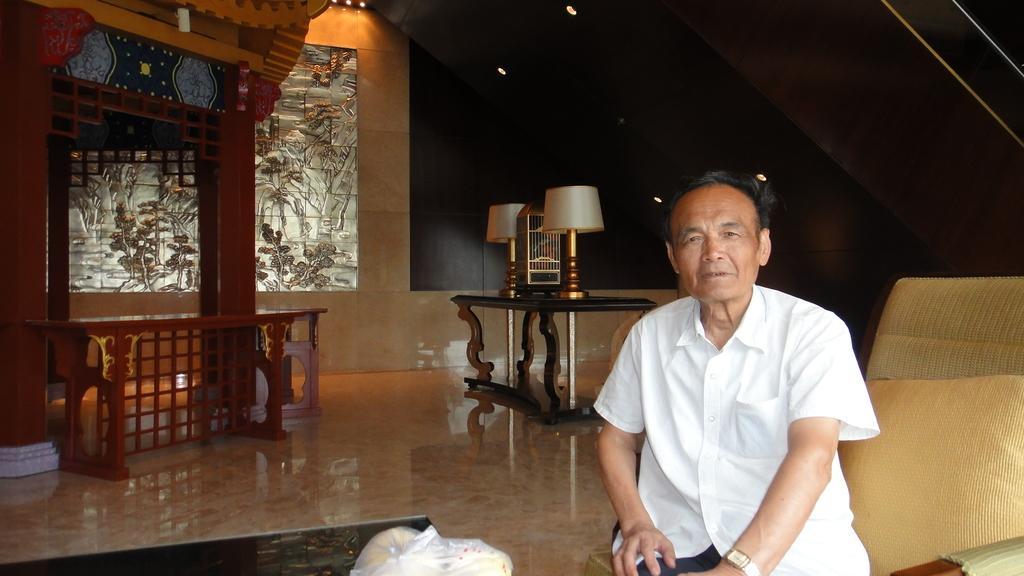In one or two sentences, can you explain what this image depicts? In this picture we can see the man sitting on the sofa and giving a pose to the camera. Behind there is a center table with two table lights. Behind there is a glass wall and wooden shed. In the front bottom side there is a marble flooring. 